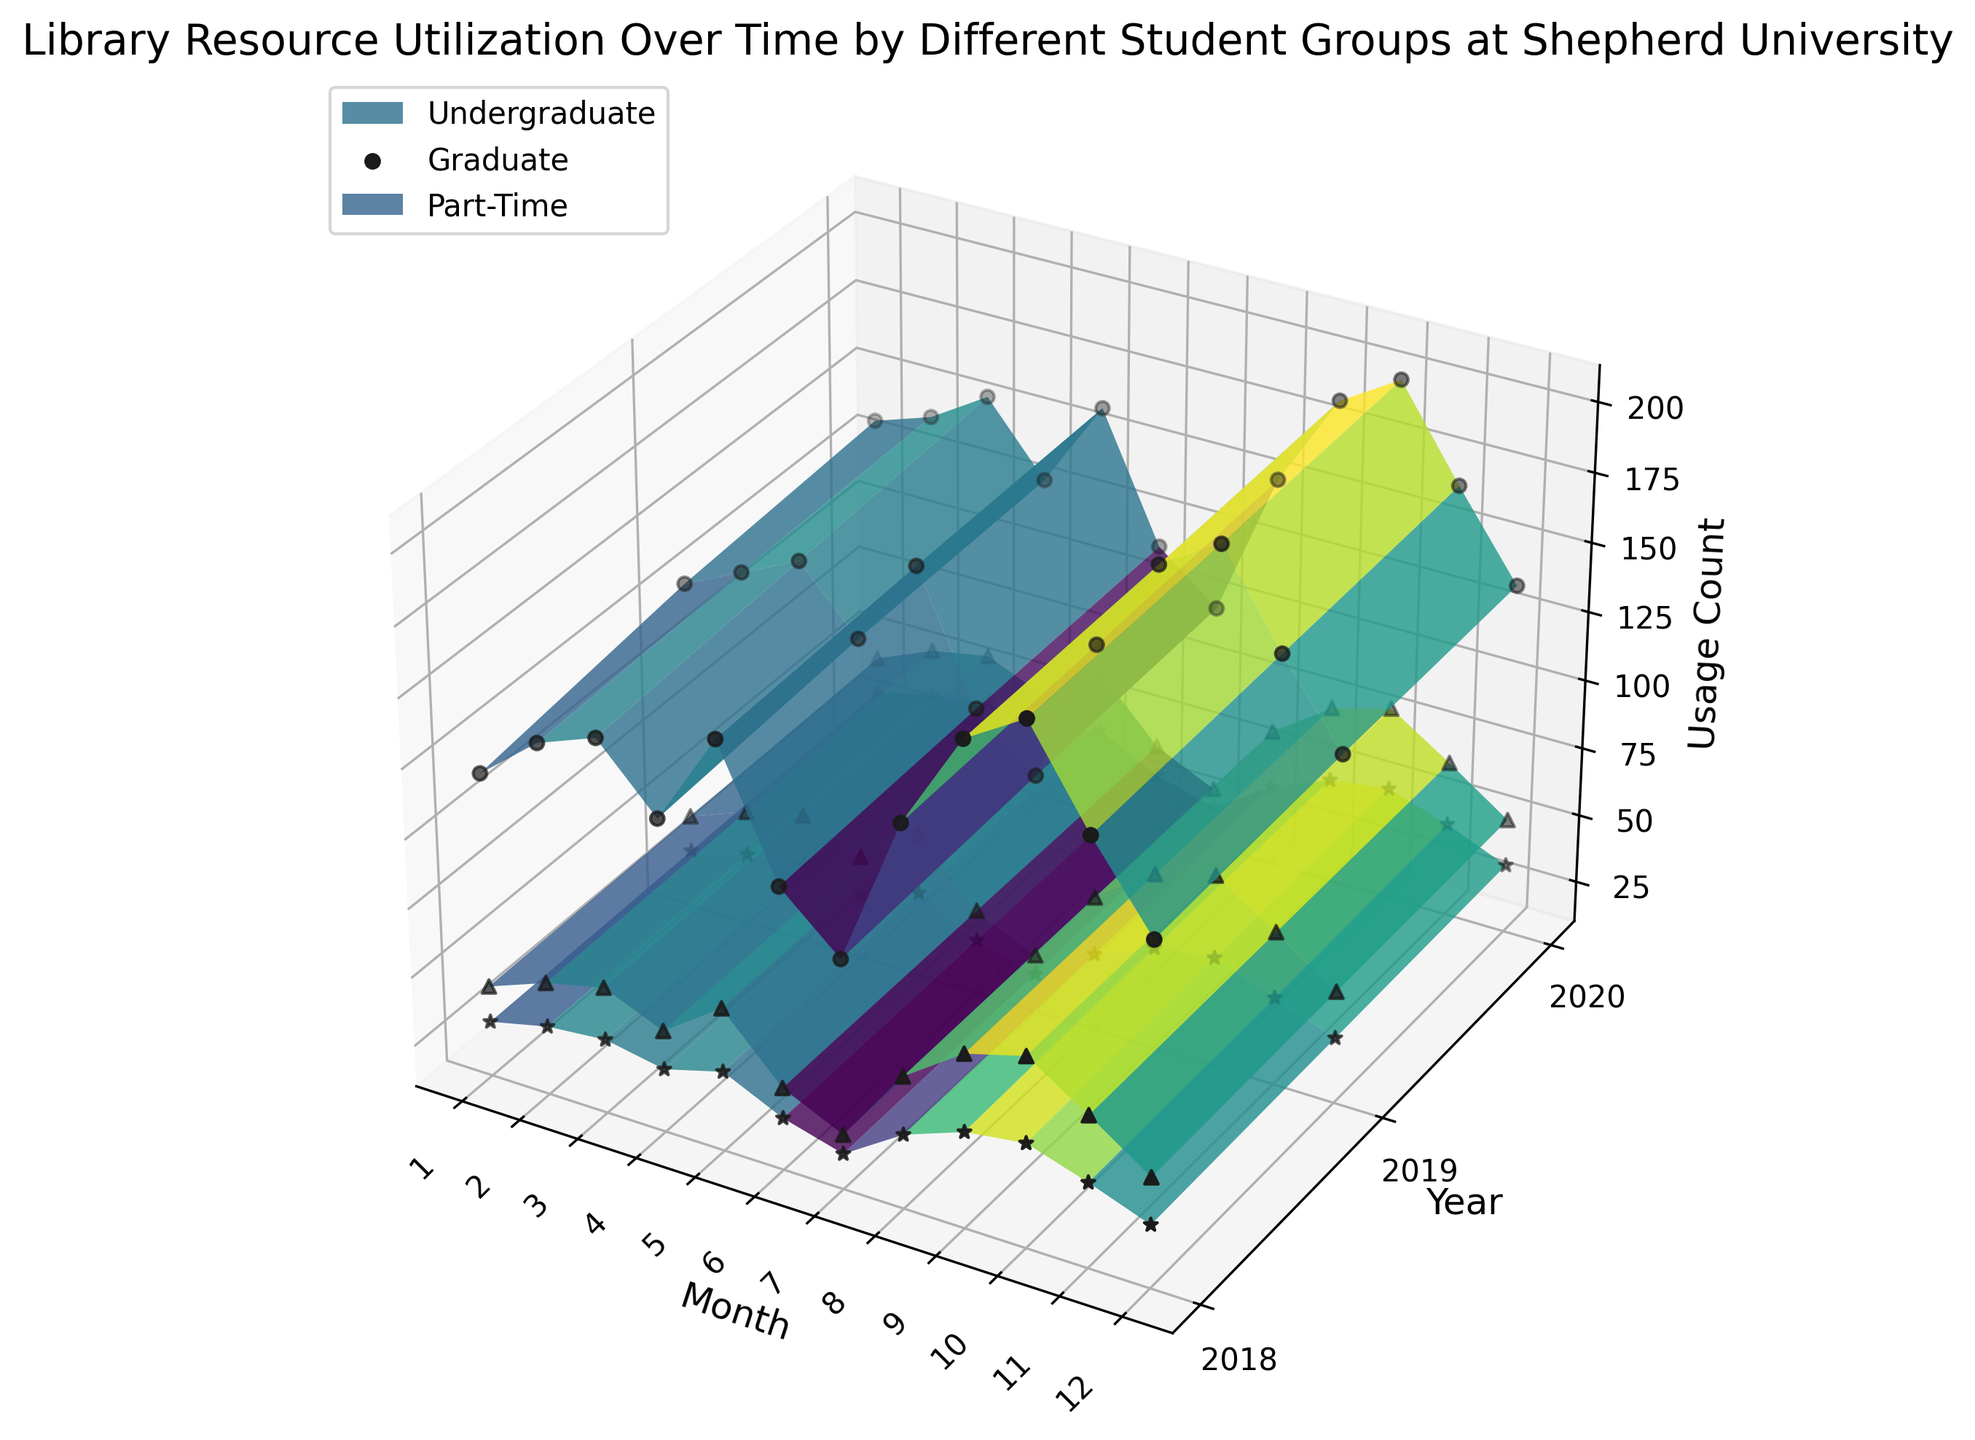Which student group had the highest library resource utilization in October 2020? Look at the height of the plots for different groups in October 2020. The undergraduate group has the tallest plot in October 2020.
Answer: Undergraduate What is the average library resource usage for the Graduate group in 2019? Find the usage counts for each month in 2019 for the Graduate group, add them up, and divide by 12. The monthly values are (44, 52, 57, 48, 63, 41, 31, 59, 74, 80, 66, 51). The sum is 666, so the average is 666 / 12 = 55.5.
Answer: 55.5 Were there any months when the Part-Time group had higher utilization than the Graduate group in 2020? Compare each month's utilization between the Part-Time and Graduate groups in 2020. In months July (25 vs 32), and October (51 vs 81), the Part-Time group had higher utilization.
Answer: No Which group showed the most significant increase in usage from January to September 2019? Calculate the difference between January and September for all groups in 2019. The differences are: Undergraduate (184 - 130 = 54), Graduate (74 - 44 = 30), and Part-Time (47 - 31 = 16). The Undergraduate group had the most significant increase.
Answer: Undergraduate What is the median usage count for the Undergraduate group across the entire period? List all usage counts for the Undergraduate group, sort them, and find the middle value. There are 36 values, so the median is the average of the 18th and 19th values: (145 + 147) / 2 = 146.
Answer: 146 How did the utilization of library resources by the Part-Time group change from June 2019 to December 2019? Check the usage counts for June (30) and December (34) in 2019. The utilization increased from 30 in June to 34 in December.
Answer: Increased Which group consistently had the highest library resource utilization throughout 2018? Compare the heights of the plots for each group throughout 2018. The undergraduate group consistently stays above the others.
Answer: Undergraduate 